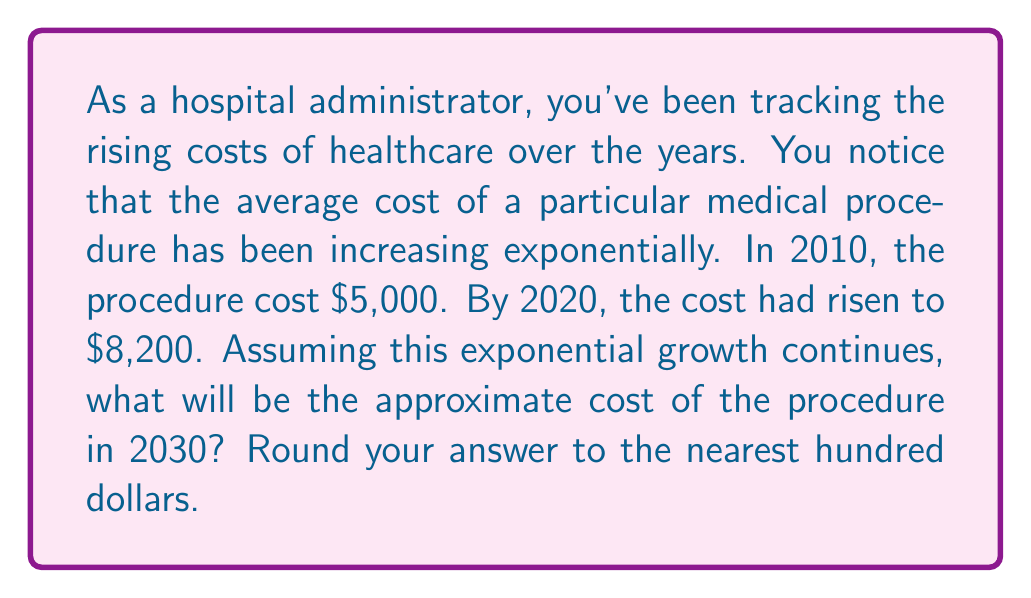Solve this math problem. To solve this problem, we'll use the exponential growth formula:

$$A = P(1 + r)^t$$

Where:
$A$ = Final amount
$P$ = Initial principal balance
$r$ = Annual growth rate (in decimal form)
$t$ = Time in years

We know:
$P = 5000$ (cost in 2010)
$A = 8200$ (cost in 2020)
$t = 10$ years (from 2010 to 2020)

Step 1: Plug these values into the formula and solve for $r$:
$$8200 = 5000(1 + r)^{10}$$

Step 2: Divide both sides by 5000:
$$1.64 = (1 + r)^{10}$$

Step 3: Take the 10th root of both sides:
$$(1.64)^{\frac{1}{10}} = 1 + r$$

Step 4: Subtract 1 from both sides:
$$r = (1.64)^{\frac{1}{10}} - 1 \approx 0.0507$$

The annual growth rate is approximately 5.07%.

Step 5: Now use this rate to project the cost in 2030 (20 years from 2010):
$$A = 5000(1 + 0.0507)^{20}$$

Step 6: Calculate the result:
$$A \approx 13,435.76$$

Step 7: Round to the nearest hundred:
$$A \approx 13,400$$
Answer: $13,400 